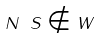Convert formula to latex. <formula><loc_0><loc_0><loc_500><loc_500>N \ S \notin W</formula> 